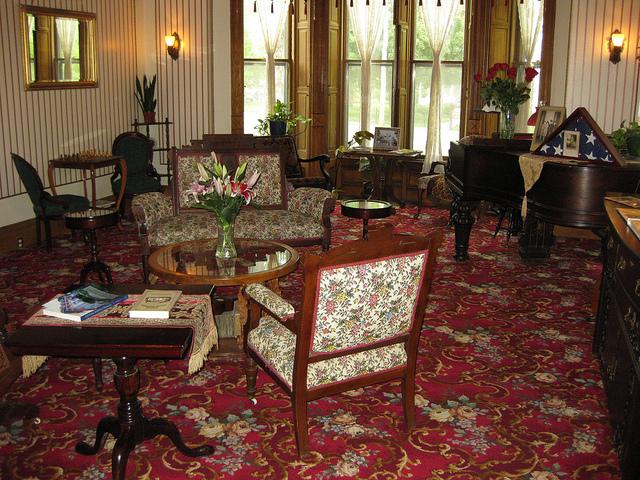What room is this?
Answer briefly. Living room. What is the triangle item sitting on the piano?
Concise answer only. Flag. Where is the mirror?
Give a very brief answer. Wall. 